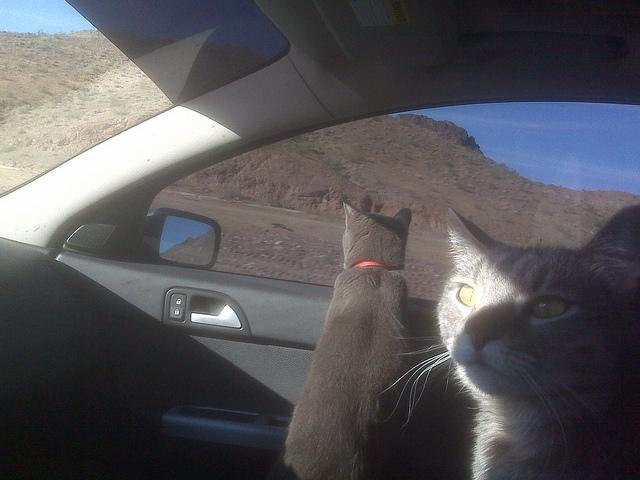Which section of the car is the cat by the window sitting at? Please explain your reasoning. front passenger. The cat is looking out the front passenger window. 